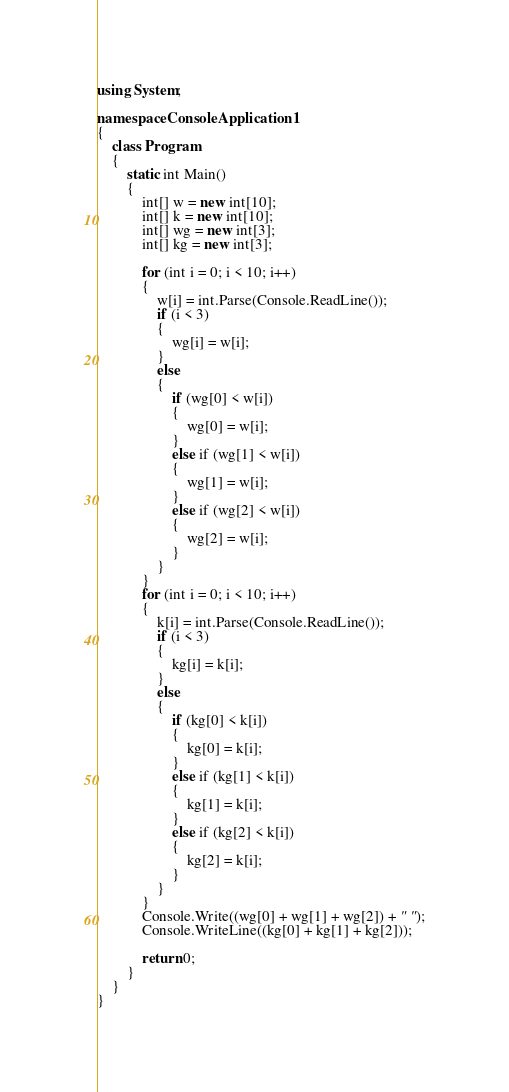<code> <loc_0><loc_0><loc_500><loc_500><_C#_>using System;

namespace ConsoleApplication1
{
    class Program
    {
        static int Main()
        {
            int[] w = new int[10];
            int[] k = new int[10];
            int[] wg = new int[3];
            int[] kg = new int[3];

            for (int i = 0; i < 10; i++)
            {
                w[i] = int.Parse(Console.ReadLine());
                if (i < 3)
                {
                    wg[i] = w[i]; 
                }
                else
                {
                    if (wg[0] < w[i])
                    {
                        wg[0] = w[i];
                    }
                    else if (wg[1] < w[i])
	                {
                        wg[1] = w[i];
	                }
                    else if (wg[2] < w[i])
	                {
                        wg[2] = w[i];
	                }
                }
            }
            for (int i = 0; i < 10; i++)
            {
                k[i] = int.Parse(Console.ReadLine());
                if (i < 3)
                {
                    kg[i] = k[i];
                }
                else
                {
                    if (kg[0] < k[i])
                    {
                        kg[0] = k[i];
                    }
                    else if (kg[1] < k[i])
                    {
                        kg[1] = k[i];
                    }
                    else if (kg[2] < k[i])
                    {
                        kg[2] = k[i];
                    }
                }
            }
            Console.Write((wg[0] + wg[1] + wg[2]) + " ");
            Console.WriteLine((kg[0] + kg[1] + kg[2]));

            return 0;
        }
    }
}</code> 